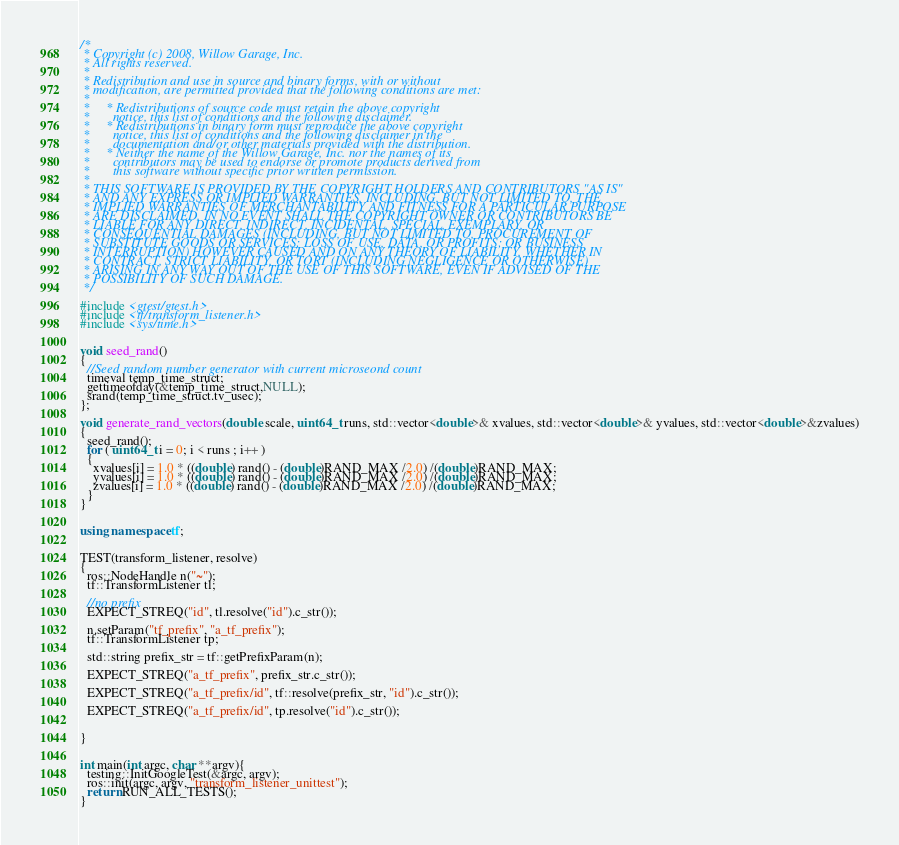Convert code to text. <code><loc_0><loc_0><loc_500><loc_500><_C++_>/*
 * Copyright (c) 2008, Willow Garage, Inc.
 * All rights reserved.
 * 
 * Redistribution and use in source and binary forms, with or without
 * modification, are permitted provided that the following conditions are met:
 * 
 *     * Redistributions of source code must retain the above copyright
 *       notice, this list of conditions and the following disclaimer.
 *     * Redistributions in binary form must reproduce the above copyright
 *       notice, this list of conditions and the following disclaimer in the
 *       documentation and/or other materials provided with the distribution.
 *     * Neither the name of the Willow Garage, Inc. nor the names of its
 *       contributors may be used to endorse or promote products derived from
 *       this software without specific prior written permission.
 * 
 * THIS SOFTWARE IS PROVIDED BY THE COPYRIGHT HOLDERS AND CONTRIBUTORS "AS IS"
 * AND ANY EXPRESS OR IMPLIED WARRANTIES, INCLUDING, BUT NOT LIMITED TO, THE
 * IMPLIED WARRANTIES OF MERCHANTABILITY AND FITNESS FOR A PARTICULAR PURPOSE
 * ARE DISCLAIMED. IN NO EVENT SHALL THE COPYRIGHT OWNER OR CONTRIBUTORS BE
 * LIABLE FOR ANY DIRECT, INDIRECT, INCIDENTAL, SPECIAL, EXEMPLARY, OR
 * CONSEQUENTIAL DAMAGES (INCLUDING, BUT NOT LIMITED TO, PROCUREMENT OF
 * SUBSTITUTE GOODS OR SERVICES; LOSS OF USE, DATA, OR PROFITS; OR BUSINESS
 * INTERRUPTION) HOWEVER CAUSED AND ON ANY THEORY OF LIABILITY, WHETHER IN
 * CONTRACT, STRICT LIABILITY, OR TORT (INCLUDING NEGLIGENCE OR OTHERWISE)
 * ARISING IN ANY WAY OUT OF THE USE OF THIS SOFTWARE, EVEN IF ADVISED OF THE
 * POSSIBILITY OF SUCH DAMAGE.
 */

#include <gtest/gtest.h>
#include <tf/transform_listener.h>
#include <sys/time.h>


void seed_rand()
{
  //Seed random number generator with current microseond count
  timeval temp_time_struct;
  gettimeofday(&temp_time_struct,NULL);
  srand(temp_time_struct.tv_usec);
};

void generate_rand_vectors(double scale, uint64_t runs, std::vector<double>& xvalues, std::vector<double>& yvalues, std::vector<double>&zvalues)
{
  seed_rand();
  for ( uint64_t i = 0; i < runs ; i++ )
  {
    xvalues[i] = 1.0 * ((double) rand() - (double)RAND_MAX /2.0) /(double)RAND_MAX;
    yvalues[i] = 1.0 * ((double) rand() - (double)RAND_MAX /2.0) /(double)RAND_MAX;
    zvalues[i] = 1.0 * ((double) rand() - (double)RAND_MAX /2.0) /(double)RAND_MAX;
  }
}


using namespace tf;


TEST(transform_listener, resolve)
{
  ros::NodeHandle n("~");
  tf::TransformListener tl; 
  
  //no prefix
  EXPECT_STREQ("id", tl.resolve("id").c_str());
  
  n.setParam("tf_prefix", "a_tf_prefix");
  tf::TransformListener tp; 

  std::string prefix_str = tf::getPrefixParam(n);

  EXPECT_STREQ("a_tf_prefix", prefix_str.c_str());

  EXPECT_STREQ("a_tf_prefix/id", tf::resolve(prefix_str, "id").c_str());

  EXPECT_STREQ("a_tf_prefix/id", tp.resolve("id").c_str());
  

}


int main(int argc, char **argv){
  testing::InitGoogleTest(&argc, argv);
  ros::init(argc, argv, "transform_listener_unittest");
  return RUN_ALL_TESTS();
}
</code> 